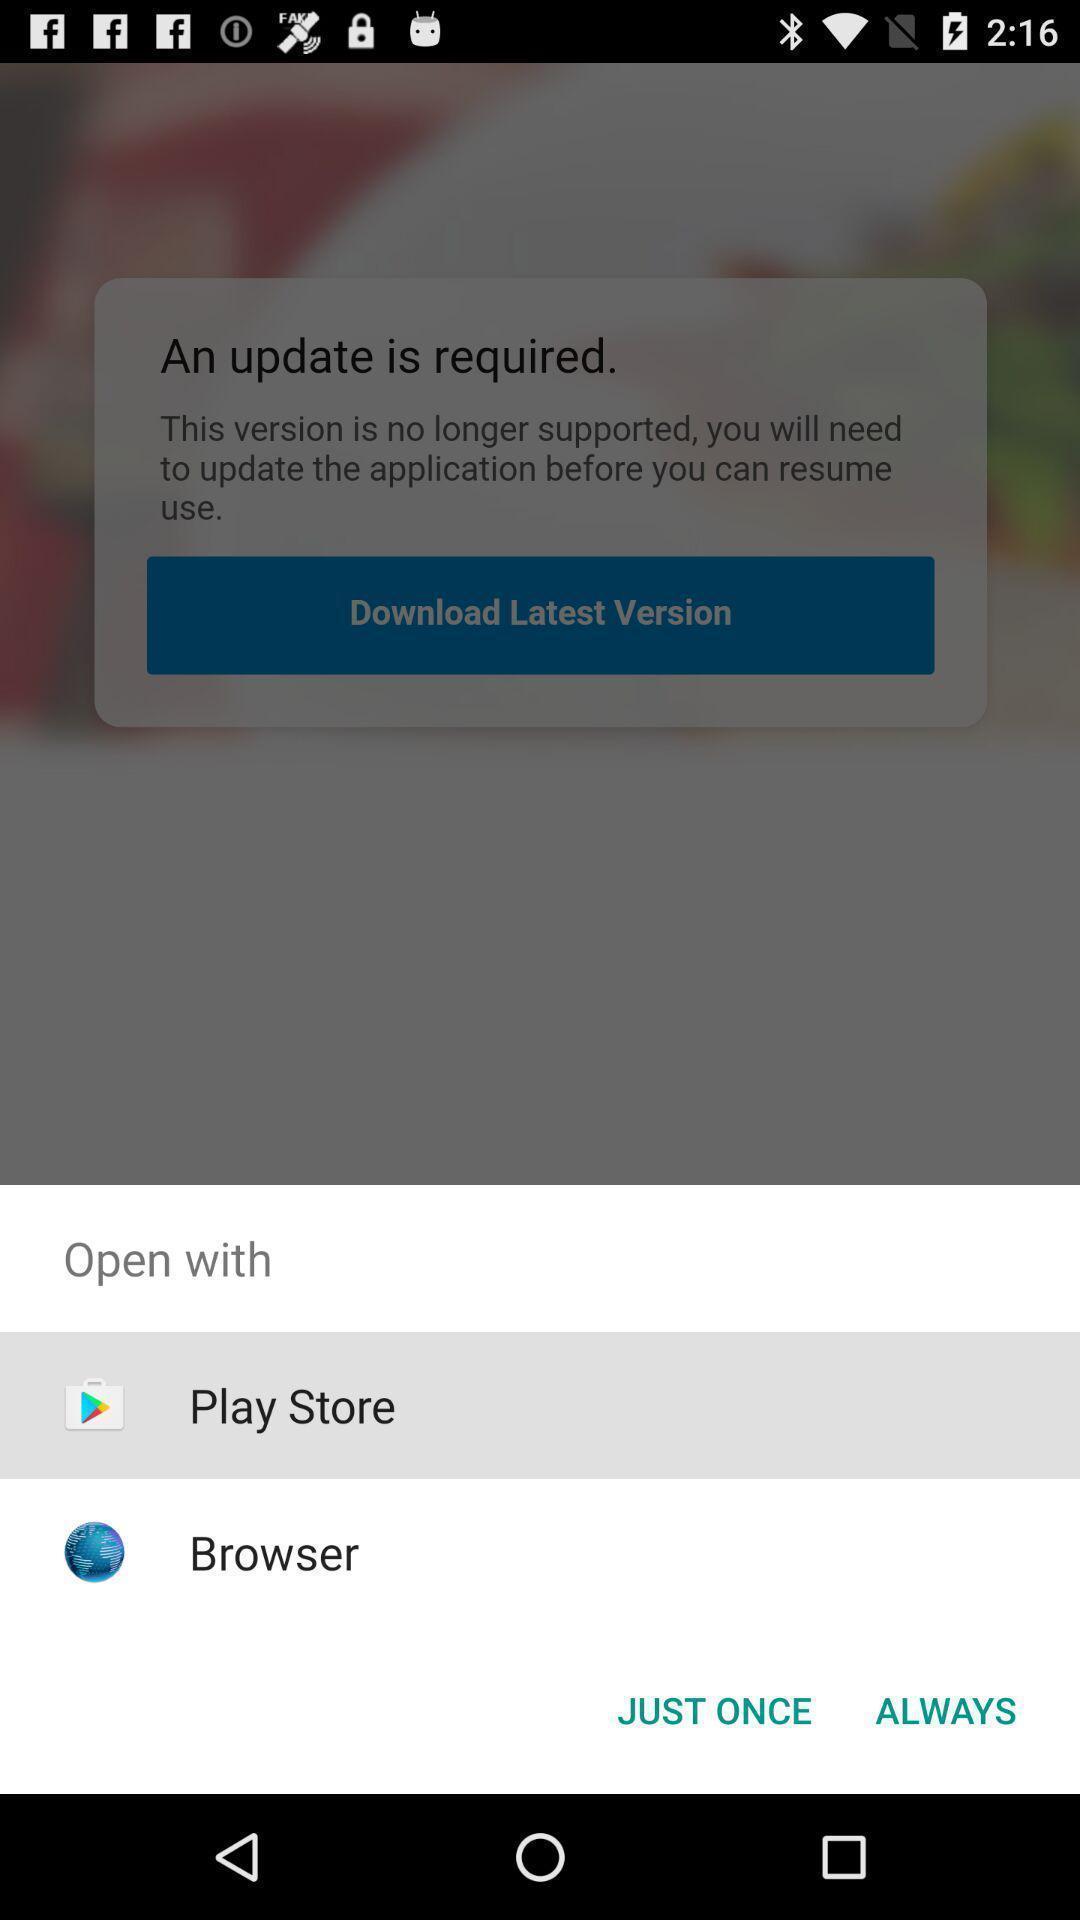Provide a detailed account of this screenshot. Popup to update the app with different options. 